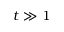Convert formula to latex. <formula><loc_0><loc_0><loc_500><loc_500>t \gg 1</formula> 